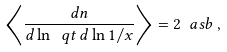Convert formula to latex. <formula><loc_0><loc_0><loc_500><loc_500>\left \langle \frac { d n } { d \ln \ q t \, d \ln 1 / x } \right \rangle = 2 \ a s b \, ,</formula> 